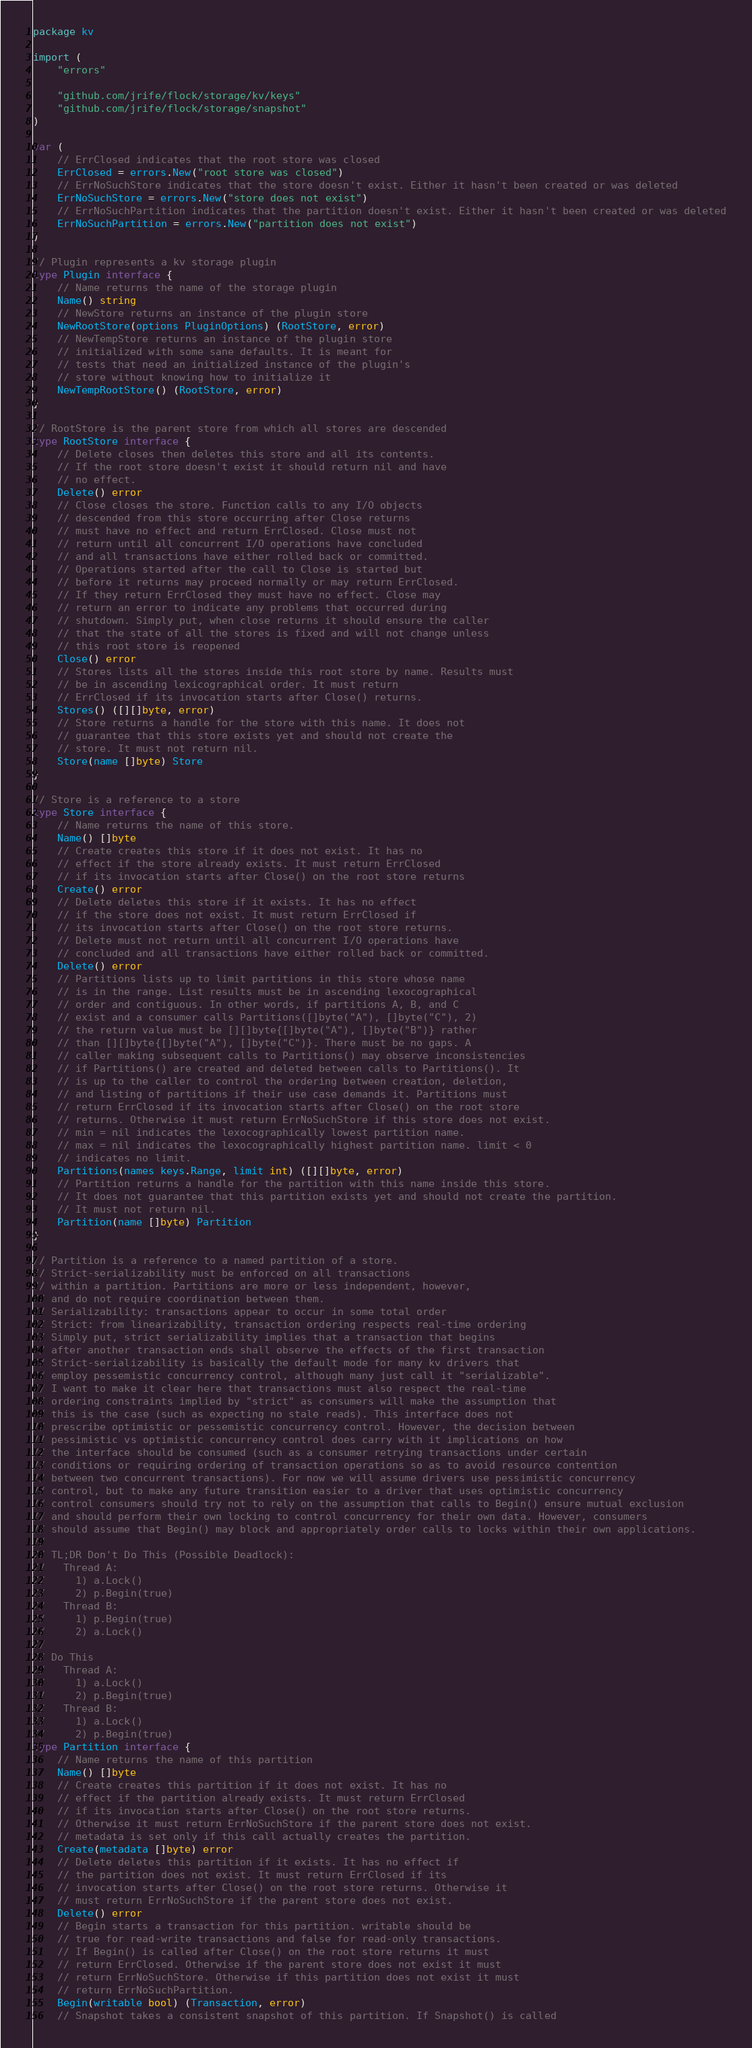Convert code to text. <code><loc_0><loc_0><loc_500><loc_500><_Go_>package kv

import (
	"errors"

	"github.com/jrife/flock/storage/kv/keys"
	"github.com/jrife/flock/storage/snapshot"
)

var (
	// ErrClosed indicates that the root store was closed
	ErrClosed = errors.New("root store was closed")
	// ErrNoSuchStore indicates that the store doesn't exist. Either it hasn't been created or was deleted
	ErrNoSuchStore = errors.New("store does not exist")
	// ErrNoSuchPartition indicates that the partition doesn't exist. Either it hasn't been created or was deleted
	ErrNoSuchPartition = errors.New("partition does not exist")
)

// Plugin represents a kv storage plugin
type Plugin interface {
	// Name returns the name of the storage plugin
	Name() string
	// NewStore returns an instance of the plugin store
	NewRootStore(options PluginOptions) (RootStore, error)
	// NewTempStore returns an instance of the plugin store
	// initialized with some sane defaults. It is meant for
	// tests that need an initialized instance of the plugin's
	// store without knowing how to initialize it
	NewTempRootStore() (RootStore, error)
}

// RootStore is the parent store from which all stores are descended
type RootStore interface {
	// Delete closes then deletes this store and all its contents.
	// If the root store doesn't exist it should return nil and have
	// no effect.
	Delete() error
	// Close closes the store. Function calls to any I/O objects
	// descended from this store occurring after Close returns
	// must have no effect and return ErrClosed. Close must not
	// return until all concurrent I/O operations have concluded
	// and all transactions have either rolled back or committed.
	// Operations started after the call to Close is started but
	// before it returns may proceed normally or may return ErrClosed.
	// If they return ErrClosed they must have no effect. Close may
	// return an error to indicate any problems that occurred during
	// shutdown. Simply put, when close returns it should ensure the caller
	// that the state of all the stores is fixed and will not change unless
	// this root store is reopened
	Close() error
	// Stores lists all the stores inside this root store by name. Results must
	// be in ascending lexicographical order. It must return
	// ErrClosed if its invocation starts after Close() returns.
	Stores() ([][]byte, error)
	// Store returns a handle for the store with this name. It does not
	// guarantee that this store exists yet and should not create the
	// store. It must not return nil.
	Store(name []byte) Store
}

// Store is a reference to a store
type Store interface {
	// Name returns the name of this store.
	Name() []byte
	// Create creates this store if it does not exist. It has no
	// effect if the store already exists. It must return ErrClosed
	// if its invocation starts after Close() on the root store returns
	Create() error
	// Delete deletes this store if it exists. It has no effect
	// if the store does not exist. It must return ErrClosed if
	// its invocation starts after Close() on the root store returns.
	// Delete must not return until all concurrent I/O operations have
	// concluded and all transactions have either rolled back or committed.
	Delete() error
	// Partitions lists up to limit partitions in this store whose name
	// is in the range. List results must be in ascending lexocographical
	// order and contiguous. In other words, if partitions A, B, and C
	// exist and a consumer calls Partitions([]byte("A"), []byte("C"), 2)
	// the return value must be [][]byte{[]byte("A"), []byte("B")} rather
	// than [][]byte{[]byte("A"), []byte("C")}. There must be no gaps. A
	// caller making subsequent calls to Partitions() may observe inconsistencies
	// if Partitions() are created and deleted between calls to Partitions(). It
	// is up to the caller to control the ordering between creation, deletion,
	// and listing of partitions if their use case demands it. Partitions must
	// return ErrClosed if its invocation starts after Close() on the root store
	// returns. Otherwise it must return ErrNoSuchStore if this store does not exist.
	// min = nil indicates the lexocographically lowest partition name.
	// max = nil indicates the lexocographically highest partition name. limit < 0
	// indicates no limit.
	Partitions(names keys.Range, limit int) ([][]byte, error)
	// Partition returns a handle for the partition with this name inside this store.
	// It does not guarantee that this partition exists yet and should not create the partition.
	// It must not return nil.
	Partition(name []byte) Partition
}

// Partition is a reference to a named partition of a store.
// Strict-serializability must be enforced on all transactions
// within a partition. Partitions are more or less independent, however,
// and do not require coordination between them.
// Serializability: transactions appear to occur in some total order
// Strict: from linearizability, transaction ordering respects real-time ordering
// Simply put, strict serializability implies that a transaction that begins
// after another transaction ends shall observe the effects of the first transaction
// Strict-serializability is basically the default mode for many kv drivers that
// employ pessemistic concurrency control, although many just call it "serializable".
// I want to make it clear here that transactions must also respect the real-time
// ordering constraints implied by "strict" as consumers will make the assumption that
// this is the case (such as expecting no stale reads). This interface does not
// prescribe optimistic or pessemistic concurrency control. However, the decision between
// pessimistic vs optimistic concurrency control does carry with it implications on how
// the interface should be consumed (such as a consumer retrying transactions under certain
// conditions or requiring ordering of transaction operations so as to avoid resource contention
// between two concurrent transactions). For now we will assume drivers use pessimistic concurrency
// control, but to make any future transition easier to a driver that uses optimistic concurrency
// control consumers should try not to rely on the assumption that calls to Begin() ensure mutual exclusion
// and should perform their own locking to control concurrency for their own data. However, consumers
// should assume that Begin() may block and appropriately order calls to locks within their own applications.
//
// TL;DR Don't Do This (Possible Deadlock):
//   Thread A:
//     1) a.Lock()
//     2) p.Begin(true)
//   Thread B:
//     1) p.Begin(true)
//     2) a.Lock()
//
// Do This
//   Thread A:
//     1) a.Lock()
//     2) p.Begin(true)
//   Thread B:
//     1) a.Lock()
//     2) p.Begin(true)
type Partition interface {
	// Name returns the name of this partition
	Name() []byte
	// Create creates this partition if it does not exist. It has no
	// effect if the partition already exists. It must return ErrClosed
	// if its invocation starts after Close() on the root store returns.
	// Otherwise it must return ErrNoSuchStore if the parent store does not exist.
	// metadata is set only if this call actually creates the partition.
	Create(metadata []byte) error
	// Delete deletes this partition if it exists. It has no effect if
	// the partition does not exist. It must return ErrClosed if its
	// invocation starts after Close() on the root store returns. Otherwise it
	// must return ErrNoSuchStore if the parent store does not exist.
	Delete() error
	// Begin starts a transaction for this partition. writable should be
	// true for read-write transactions and false for read-only transactions.
	// If Begin() is called after Close() on the root store returns it must
	// return ErrClosed. Otherwise if the parent store does not exist it must
	// return ErrNoSuchStore. Otherwise if this partition does not exist it must
	// return ErrNoSuchPartition.
	Begin(writable bool) (Transaction, error)
	// Snapshot takes a consistent snapshot of this partition. If Snapshot() is called</code> 